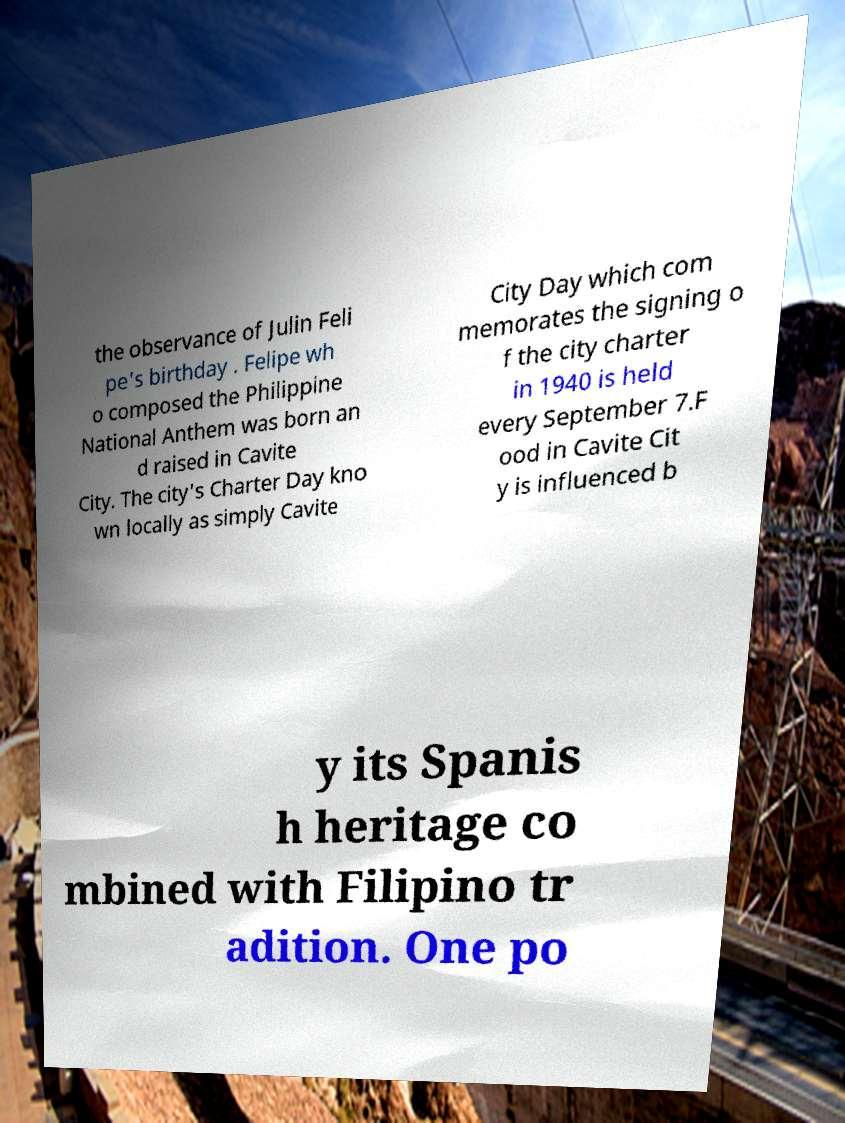Can you read and provide the text displayed in the image?This photo seems to have some interesting text. Can you extract and type it out for me? the observance of Julin Feli pe's birthday . Felipe wh o composed the Philippine National Anthem was born an d raised in Cavite City. The city's Charter Day kno wn locally as simply Cavite City Day which com memorates the signing o f the city charter in 1940 is held every September 7.F ood in Cavite Cit y is influenced b y its Spanis h heritage co mbined with Filipino tr adition. One po 